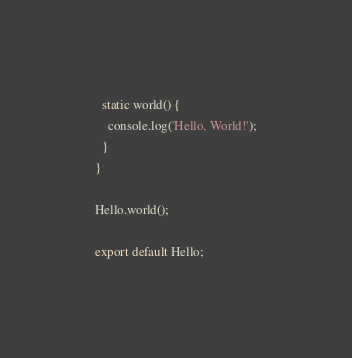Convert code to text. <code><loc_0><loc_0><loc_500><loc_500><_JavaScript_>  static world() {
    console.log('Hello, World!');
  }
}

Hello.world();

export default Hello;
</code> 